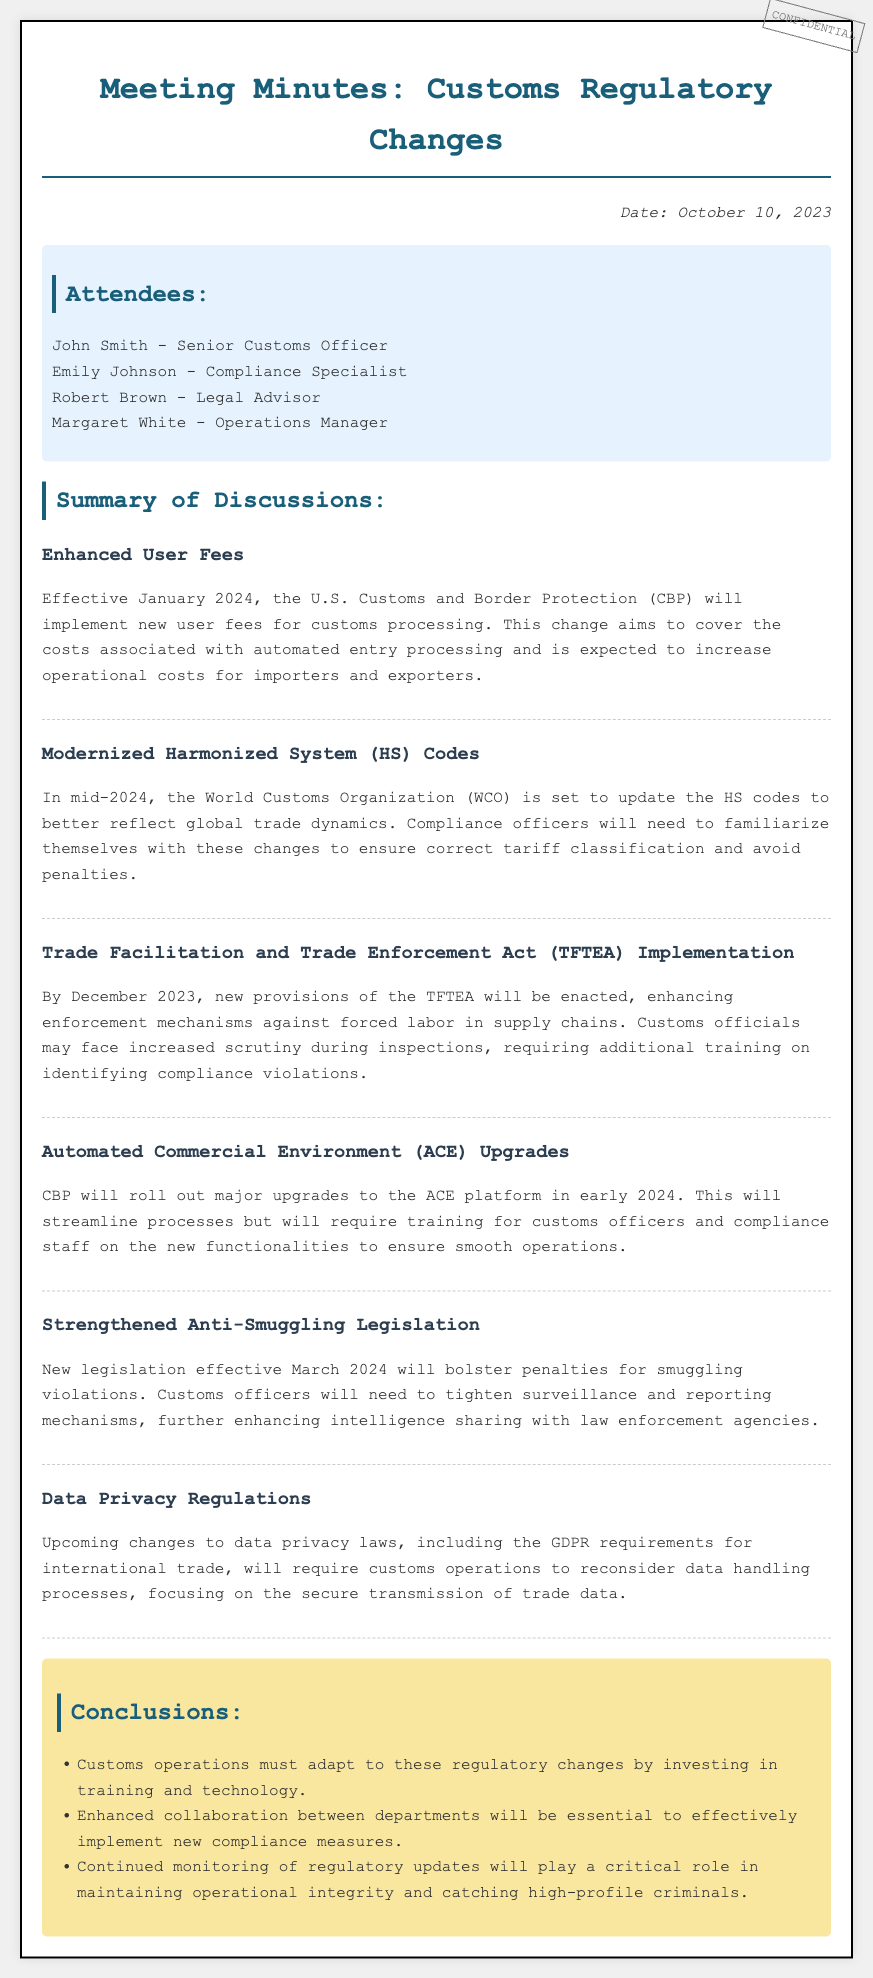What is the date of the meeting? The meeting date is provided in the document to establish when the discussions took place.
Answer: October 10, 2023 Who is the operations manager in the meeting? The document lists participants, identifying their respective roles, including the operations manager.
Answer: Margaret White What are the new user fees effective from? The implementation date for the new user fees is significant for customs processing cost adjustments.
Answer: January 2024 When will the HS code updates take place? The timeline for HS code updates is relevant for compliance preparation among customs officials.
Answer: Mid-2024 What enforcement provisions are enacted by December 2023? This question refers to specific regulations that affect operational procedures and compliance training.
Answer: TFTEA What is a key requirement for customs operations regarding data handling? The document outlines crucial implications of regulatory changes, indicating the need for secure data practices.
Answer: Secure transmission of trade data What is emphasized for customs officers regarding the new legislation? The document highlights necessary adjustments customs officers must make in response to regulatory enhancements.
Answer: Tighten surveillance and reporting mechanisms What is essential for implementing new compliance measures? Collaboration across departments is noted as vital for effective operations according to the meeting conclusions.
Answer: Enhanced collaboration 